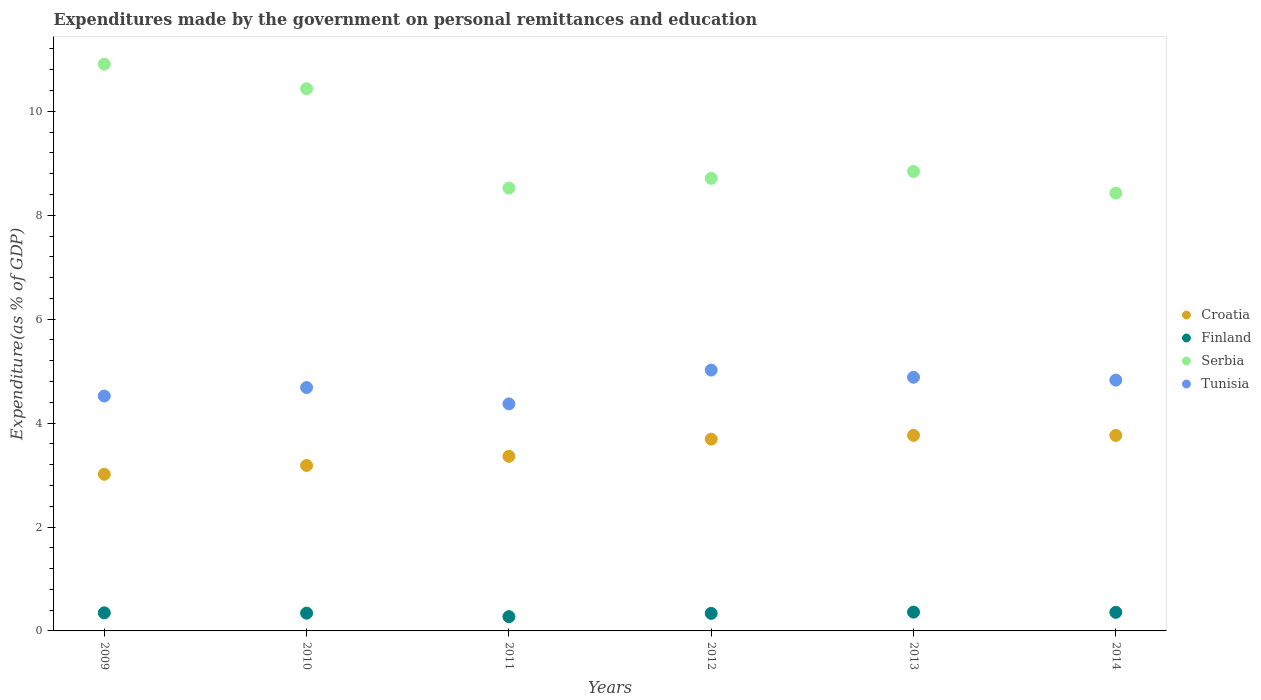Is the number of dotlines equal to the number of legend labels?
Make the answer very short. Yes. What is the expenditures made by the government on personal remittances and education in Serbia in 2010?
Offer a very short reply. 10.43. Across all years, what is the maximum expenditures made by the government on personal remittances and education in Serbia?
Your answer should be very brief. 10.91. Across all years, what is the minimum expenditures made by the government on personal remittances and education in Croatia?
Ensure brevity in your answer.  3.01. In which year was the expenditures made by the government on personal remittances and education in Croatia maximum?
Provide a succinct answer. 2013. In which year was the expenditures made by the government on personal remittances and education in Tunisia minimum?
Offer a very short reply. 2011. What is the total expenditures made by the government on personal remittances and education in Croatia in the graph?
Your response must be concise. 20.78. What is the difference between the expenditures made by the government on personal remittances and education in Serbia in 2009 and that in 2010?
Keep it short and to the point. 0.47. What is the difference between the expenditures made by the government on personal remittances and education in Croatia in 2011 and the expenditures made by the government on personal remittances and education in Finland in 2009?
Your answer should be very brief. 3.01. What is the average expenditures made by the government on personal remittances and education in Finland per year?
Make the answer very short. 0.34. In the year 2010, what is the difference between the expenditures made by the government on personal remittances and education in Croatia and expenditures made by the government on personal remittances and education in Tunisia?
Your answer should be compact. -1.5. What is the ratio of the expenditures made by the government on personal remittances and education in Serbia in 2012 to that in 2014?
Give a very brief answer. 1.03. Is the difference between the expenditures made by the government on personal remittances and education in Croatia in 2009 and 2011 greater than the difference between the expenditures made by the government on personal remittances and education in Tunisia in 2009 and 2011?
Your answer should be very brief. No. What is the difference between the highest and the second highest expenditures made by the government on personal remittances and education in Tunisia?
Ensure brevity in your answer.  0.14. What is the difference between the highest and the lowest expenditures made by the government on personal remittances and education in Finland?
Your answer should be very brief. 0.09. In how many years, is the expenditures made by the government on personal remittances and education in Croatia greater than the average expenditures made by the government on personal remittances and education in Croatia taken over all years?
Provide a short and direct response. 3. Is it the case that in every year, the sum of the expenditures made by the government on personal remittances and education in Finland and expenditures made by the government on personal remittances and education in Serbia  is greater than the sum of expenditures made by the government on personal remittances and education in Croatia and expenditures made by the government on personal remittances and education in Tunisia?
Ensure brevity in your answer.  No. Is it the case that in every year, the sum of the expenditures made by the government on personal remittances and education in Finland and expenditures made by the government on personal remittances and education in Serbia  is greater than the expenditures made by the government on personal remittances and education in Tunisia?
Your answer should be compact. Yes. Does the expenditures made by the government on personal remittances and education in Croatia monotonically increase over the years?
Your answer should be very brief. No. Does the graph contain grids?
Your answer should be very brief. No. Where does the legend appear in the graph?
Provide a short and direct response. Center right. How are the legend labels stacked?
Ensure brevity in your answer.  Vertical. What is the title of the graph?
Ensure brevity in your answer.  Expenditures made by the government on personal remittances and education. What is the label or title of the X-axis?
Offer a terse response. Years. What is the label or title of the Y-axis?
Provide a short and direct response. Expenditure(as % of GDP). What is the Expenditure(as % of GDP) of Croatia in 2009?
Keep it short and to the point. 3.01. What is the Expenditure(as % of GDP) of Finland in 2009?
Your response must be concise. 0.35. What is the Expenditure(as % of GDP) of Serbia in 2009?
Make the answer very short. 10.91. What is the Expenditure(as % of GDP) in Tunisia in 2009?
Your answer should be compact. 4.52. What is the Expenditure(as % of GDP) in Croatia in 2010?
Your answer should be compact. 3.18. What is the Expenditure(as % of GDP) in Finland in 2010?
Your response must be concise. 0.34. What is the Expenditure(as % of GDP) in Serbia in 2010?
Give a very brief answer. 10.43. What is the Expenditure(as % of GDP) of Tunisia in 2010?
Give a very brief answer. 4.68. What is the Expenditure(as % of GDP) of Croatia in 2011?
Offer a terse response. 3.36. What is the Expenditure(as % of GDP) in Finland in 2011?
Ensure brevity in your answer.  0.27. What is the Expenditure(as % of GDP) of Serbia in 2011?
Your answer should be very brief. 8.52. What is the Expenditure(as % of GDP) in Tunisia in 2011?
Offer a very short reply. 4.37. What is the Expenditure(as % of GDP) of Croatia in 2012?
Your response must be concise. 3.69. What is the Expenditure(as % of GDP) in Finland in 2012?
Provide a succinct answer. 0.34. What is the Expenditure(as % of GDP) of Serbia in 2012?
Give a very brief answer. 8.71. What is the Expenditure(as % of GDP) in Tunisia in 2012?
Provide a succinct answer. 5.02. What is the Expenditure(as % of GDP) of Croatia in 2013?
Keep it short and to the point. 3.76. What is the Expenditure(as % of GDP) of Finland in 2013?
Make the answer very short. 0.36. What is the Expenditure(as % of GDP) of Serbia in 2013?
Ensure brevity in your answer.  8.84. What is the Expenditure(as % of GDP) of Tunisia in 2013?
Your answer should be compact. 4.88. What is the Expenditure(as % of GDP) in Croatia in 2014?
Offer a very short reply. 3.76. What is the Expenditure(as % of GDP) of Finland in 2014?
Give a very brief answer. 0.36. What is the Expenditure(as % of GDP) in Serbia in 2014?
Ensure brevity in your answer.  8.43. What is the Expenditure(as % of GDP) of Tunisia in 2014?
Give a very brief answer. 4.83. Across all years, what is the maximum Expenditure(as % of GDP) of Croatia?
Offer a very short reply. 3.76. Across all years, what is the maximum Expenditure(as % of GDP) in Finland?
Provide a succinct answer. 0.36. Across all years, what is the maximum Expenditure(as % of GDP) in Serbia?
Keep it short and to the point. 10.91. Across all years, what is the maximum Expenditure(as % of GDP) in Tunisia?
Keep it short and to the point. 5.02. Across all years, what is the minimum Expenditure(as % of GDP) in Croatia?
Ensure brevity in your answer.  3.01. Across all years, what is the minimum Expenditure(as % of GDP) in Finland?
Offer a very short reply. 0.27. Across all years, what is the minimum Expenditure(as % of GDP) in Serbia?
Provide a short and direct response. 8.43. Across all years, what is the minimum Expenditure(as % of GDP) in Tunisia?
Keep it short and to the point. 4.37. What is the total Expenditure(as % of GDP) in Croatia in the graph?
Your answer should be compact. 20.78. What is the total Expenditure(as % of GDP) in Finland in the graph?
Your response must be concise. 2.02. What is the total Expenditure(as % of GDP) in Serbia in the graph?
Offer a very short reply. 55.84. What is the total Expenditure(as % of GDP) in Tunisia in the graph?
Your answer should be very brief. 28.3. What is the difference between the Expenditure(as % of GDP) in Croatia in 2009 and that in 2010?
Ensure brevity in your answer.  -0.17. What is the difference between the Expenditure(as % of GDP) of Finland in 2009 and that in 2010?
Offer a very short reply. 0.01. What is the difference between the Expenditure(as % of GDP) in Serbia in 2009 and that in 2010?
Provide a succinct answer. 0.47. What is the difference between the Expenditure(as % of GDP) of Tunisia in 2009 and that in 2010?
Your response must be concise. -0.16. What is the difference between the Expenditure(as % of GDP) of Croatia in 2009 and that in 2011?
Make the answer very short. -0.35. What is the difference between the Expenditure(as % of GDP) of Finland in 2009 and that in 2011?
Provide a short and direct response. 0.07. What is the difference between the Expenditure(as % of GDP) of Serbia in 2009 and that in 2011?
Keep it short and to the point. 2.38. What is the difference between the Expenditure(as % of GDP) in Tunisia in 2009 and that in 2011?
Your answer should be very brief. 0.15. What is the difference between the Expenditure(as % of GDP) of Croatia in 2009 and that in 2012?
Provide a succinct answer. -0.68. What is the difference between the Expenditure(as % of GDP) in Finland in 2009 and that in 2012?
Give a very brief answer. 0.01. What is the difference between the Expenditure(as % of GDP) in Serbia in 2009 and that in 2012?
Ensure brevity in your answer.  2.2. What is the difference between the Expenditure(as % of GDP) in Tunisia in 2009 and that in 2012?
Make the answer very short. -0.5. What is the difference between the Expenditure(as % of GDP) of Croatia in 2009 and that in 2013?
Your answer should be very brief. -0.75. What is the difference between the Expenditure(as % of GDP) in Finland in 2009 and that in 2013?
Provide a succinct answer. -0.01. What is the difference between the Expenditure(as % of GDP) of Serbia in 2009 and that in 2013?
Give a very brief answer. 2.06. What is the difference between the Expenditure(as % of GDP) in Tunisia in 2009 and that in 2013?
Your response must be concise. -0.36. What is the difference between the Expenditure(as % of GDP) in Croatia in 2009 and that in 2014?
Your answer should be compact. -0.75. What is the difference between the Expenditure(as % of GDP) in Finland in 2009 and that in 2014?
Your answer should be compact. -0.01. What is the difference between the Expenditure(as % of GDP) in Serbia in 2009 and that in 2014?
Make the answer very short. 2.48. What is the difference between the Expenditure(as % of GDP) in Tunisia in 2009 and that in 2014?
Ensure brevity in your answer.  -0.31. What is the difference between the Expenditure(as % of GDP) in Croatia in 2010 and that in 2011?
Ensure brevity in your answer.  -0.18. What is the difference between the Expenditure(as % of GDP) of Finland in 2010 and that in 2011?
Your answer should be very brief. 0.07. What is the difference between the Expenditure(as % of GDP) in Serbia in 2010 and that in 2011?
Your response must be concise. 1.91. What is the difference between the Expenditure(as % of GDP) of Tunisia in 2010 and that in 2011?
Offer a terse response. 0.31. What is the difference between the Expenditure(as % of GDP) of Croatia in 2010 and that in 2012?
Your response must be concise. -0.51. What is the difference between the Expenditure(as % of GDP) in Finland in 2010 and that in 2012?
Give a very brief answer. 0. What is the difference between the Expenditure(as % of GDP) of Serbia in 2010 and that in 2012?
Your answer should be compact. 1.72. What is the difference between the Expenditure(as % of GDP) in Tunisia in 2010 and that in 2012?
Offer a terse response. -0.34. What is the difference between the Expenditure(as % of GDP) of Croatia in 2010 and that in 2013?
Give a very brief answer. -0.58. What is the difference between the Expenditure(as % of GDP) in Finland in 2010 and that in 2013?
Provide a short and direct response. -0.02. What is the difference between the Expenditure(as % of GDP) in Serbia in 2010 and that in 2013?
Ensure brevity in your answer.  1.59. What is the difference between the Expenditure(as % of GDP) in Tunisia in 2010 and that in 2013?
Your answer should be compact. -0.2. What is the difference between the Expenditure(as % of GDP) of Croatia in 2010 and that in 2014?
Your answer should be very brief. -0.58. What is the difference between the Expenditure(as % of GDP) of Finland in 2010 and that in 2014?
Keep it short and to the point. -0.02. What is the difference between the Expenditure(as % of GDP) in Serbia in 2010 and that in 2014?
Offer a terse response. 2.01. What is the difference between the Expenditure(as % of GDP) in Tunisia in 2010 and that in 2014?
Your answer should be compact. -0.14. What is the difference between the Expenditure(as % of GDP) of Croatia in 2011 and that in 2012?
Offer a terse response. -0.33. What is the difference between the Expenditure(as % of GDP) of Finland in 2011 and that in 2012?
Offer a terse response. -0.06. What is the difference between the Expenditure(as % of GDP) in Serbia in 2011 and that in 2012?
Keep it short and to the point. -0.19. What is the difference between the Expenditure(as % of GDP) of Tunisia in 2011 and that in 2012?
Keep it short and to the point. -0.65. What is the difference between the Expenditure(as % of GDP) of Croatia in 2011 and that in 2013?
Your response must be concise. -0.4. What is the difference between the Expenditure(as % of GDP) of Finland in 2011 and that in 2013?
Your response must be concise. -0.09. What is the difference between the Expenditure(as % of GDP) in Serbia in 2011 and that in 2013?
Your answer should be very brief. -0.32. What is the difference between the Expenditure(as % of GDP) of Tunisia in 2011 and that in 2013?
Ensure brevity in your answer.  -0.51. What is the difference between the Expenditure(as % of GDP) in Croatia in 2011 and that in 2014?
Your answer should be very brief. -0.4. What is the difference between the Expenditure(as % of GDP) in Finland in 2011 and that in 2014?
Make the answer very short. -0.08. What is the difference between the Expenditure(as % of GDP) of Serbia in 2011 and that in 2014?
Offer a very short reply. 0.1. What is the difference between the Expenditure(as % of GDP) of Tunisia in 2011 and that in 2014?
Offer a very short reply. -0.46. What is the difference between the Expenditure(as % of GDP) in Croatia in 2012 and that in 2013?
Your answer should be very brief. -0.07. What is the difference between the Expenditure(as % of GDP) of Finland in 2012 and that in 2013?
Give a very brief answer. -0.02. What is the difference between the Expenditure(as % of GDP) of Serbia in 2012 and that in 2013?
Make the answer very short. -0.13. What is the difference between the Expenditure(as % of GDP) of Tunisia in 2012 and that in 2013?
Offer a terse response. 0.14. What is the difference between the Expenditure(as % of GDP) in Croatia in 2012 and that in 2014?
Your answer should be very brief. -0.07. What is the difference between the Expenditure(as % of GDP) in Finland in 2012 and that in 2014?
Your answer should be very brief. -0.02. What is the difference between the Expenditure(as % of GDP) of Serbia in 2012 and that in 2014?
Ensure brevity in your answer.  0.28. What is the difference between the Expenditure(as % of GDP) of Tunisia in 2012 and that in 2014?
Provide a succinct answer. 0.19. What is the difference between the Expenditure(as % of GDP) of Croatia in 2013 and that in 2014?
Keep it short and to the point. 0. What is the difference between the Expenditure(as % of GDP) of Finland in 2013 and that in 2014?
Your answer should be very brief. 0. What is the difference between the Expenditure(as % of GDP) of Serbia in 2013 and that in 2014?
Ensure brevity in your answer.  0.42. What is the difference between the Expenditure(as % of GDP) of Tunisia in 2013 and that in 2014?
Provide a succinct answer. 0.05. What is the difference between the Expenditure(as % of GDP) of Croatia in 2009 and the Expenditure(as % of GDP) of Finland in 2010?
Keep it short and to the point. 2.67. What is the difference between the Expenditure(as % of GDP) of Croatia in 2009 and the Expenditure(as % of GDP) of Serbia in 2010?
Offer a very short reply. -7.42. What is the difference between the Expenditure(as % of GDP) in Croatia in 2009 and the Expenditure(as % of GDP) in Tunisia in 2010?
Provide a short and direct response. -1.67. What is the difference between the Expenditure(as % of GDP) of Finland in 2009 and the Expenditure(as % of GDP) of Serbia in 2010?
Offer a terse response. -10.09. What is the difference between the Expenditure(as % of GDP) of Finland in 2009 and the Expenditure(as % of GDP) of Tunisia in 2010?
Keep it short and to the point. -4.34. What is the difference between the Expenditure(as % of GDP) in Serbia in 2009 and the Expenditure(as % of GDP) in Tunisia in 2010?
Make the answer very short. 6.22. What is the difference between the Expenditure(as % of GDP) of Croatia in 2009 and the Expenditure(as % of GDP) of Finland in 2011?
Make the answer very short. 2.74. What is the difference between the Expenditure(as % of GDP) in Croatia in 2009 and the Expenditure(as % of GDP) in Serbia in 2011?
Provide a succinct answer. -5.51. What is the difference between the Expenditure(as % of GDP) of Croatia in 2009 and the Expenditure(as % of GDP) of Tunisia in 2011?
Keep it short and to the point. -1.35. What is the difference between the Expenditure(as % of GDP) in Finland in 2009 and the Expenditure(as % of GDP) in Serbia in 2011?
Provide a succinct answer. -8.17. What is the difference between the Expenditure(as % of GDP) of Finland in 2009 and the Expenditure(as % of GDP) of Tunisia in 2011?
Provide a succinct answer. -4.02. What is the difference between the Expenditure(as % of GDP) of Serbia in 2009 and the Expenditure(as % of GDP) of Tunisia in 2011?
Offer a very short reply. 6.54. What is the difference between the Expenditure(as % of GDP) of Croatia in 2009 and the Expenditure(as % of GDP) of Finland in 2012?
Give a very brief answer. 2.68. What is the difference between the Expenditure(as % of GDP) of Croatia in 2009 and the Expenditure(as % of GDP) of Serbia in 2012?
Ensure brevity in your answer.  -5.7. What is the difference between the Expenditure(as % of GDP) of Croatia in 2009 and the Expenditure(as % of GDP) of Tunisia in 2012?
Make the answer very short. -2.01. What is the difference between the Expenditure(as % of GDP) of Finland in 2009 and the Expenditure(as % of GDP) of Serbia in 2012?
Your answer should be compact. -8.36. What is the difference between the Expenditure(as % of GDP) in Finland in 2009 and the Expenditure(as % of GDP) in Tunisia in 2012?
Make the answer very short. -4.67. What is the difference between the Expenditure(as % of GDP) of Serbia in 2009 and the Expenditure(as % of GDP) of Tunisia in 2012?
Provide a succinct answer. 5.89. What is the difference between the Expenditure(as % of GDP) of Croatia in 2009 and the Expenditure(as % of GDP) of Finland in 2013?
Provide a short and direct response. 2.65. What is the difference between the Expenditure(as % of GDP) in Croatia in 2009 and the Expenditure(as % of GDP) in Serbia in 2013?
Provide a succinct answer. -5.83. What is the difference between the Expenditure(as % of GDP) of Croatia in 2009 and the Expenditure(as % of GDP) of Tunisia in 2013?
Offer a terse response. -1.87. What is the difference between the Expenditure(as % of GDP) of Finland in 2009 and the Expenditure(as % of GDP) of Serbia in 2013?
Your response must be concise. -8.49. What is the difference between the Expenditure(as % of GDP) in Finland in 2009 and the Expenditure(as % of GDP) in Tunisia in 2013?
Offer a terse response. -4.53. What is the difference between the Expenditure(as % of GDP) in Serbia in 2009 and the Expenditure(as % of GDP) in Tunisia in 2013?
Provide a short and direct response. 6.03. What is the difference between the Expenditure(as % of GDP) of Croatia in 2009 and the Expenditure(as % of GDP) of Finland in 2014?
Your answer should be compact. 2.66. What is the difference between the Expenditure(as % of GDP) in Croatia in 2009 and the Expenditure(as % of GDP) in Serbia in 2014?
Ensure brevity in your answer.  -5.41. What is the difference between the Expenditure(as % of GDP) in Croatia in 2009 and the Expenditure(as % of GDP) in Tunisia in 2014?
Provide a short and direct response. -1.81. What is the difference between the Expenditure(as % of GDP) in Finland in 2009 and the Expenditure(as % of GDP) in Serbia in 2014?
Provide a succinct answer. -8.08. What is the difference between the Expenditure(as % of GDP) in Finland in 2009 and the Expenditure(as % of GDP) in Tunisia in 2014?
Provide a succinct answer. -4.48. What is the difference between the Expenditure(as % of GDP) in Serbia in 2009 and the Expenditure(as % of GDP) in Tunisia in 2014?
Make the answer very short. 6.08. What is the difference between the Expenditure(as % of GDP) in Croatia in 2010 and the Expenditure(as % of GDP) in Finland in 2011?
Make the answer very short. 2.91. What is the difference between the Expenditure(as % of GDP) of Croatia in 2010 and the Expenditure(as % of GDP) of Serbia in 2011?
Give a very brief answer. -5.34. What is the difference between the Expenditure(as % of GDP) of Croatia in 2010 and the Expenditure(as % of GDP) of Tunisia in 2011?
Give a very brief answer. -1.19. What is the difference between the Expenditure(as % of GDP) of Finland in 2010 and the Expenditure(as % of GDP) of Serbia in 2011?
Keep it short and to the point. -8.18. What is the difference between the Expenditure(as % of GDP) of Finland in 2010 and the Expenditure(as % of GDP) of Tunisia in 2011?
Give a very brief answer. -4.03. What is the difference between the Expenditure(as % of GDP) of Serbia in 2010 and the Expenditure(as % of GDP) of Tunisia in 2011?
Your answer should be compact. 6.07. What is the difference between the Expenditure(as % of GDP) of Croatia in 2010 and the Expenditure(as % of GDP) of Finland in 2012?
Make the answer very short. 2.85. What is the difference between the Expenditure(as % of GDP) in Croatia in 2010 and the Expenditure(as % of GDP) in Serbia in 2012?
Your answer should be very brief. -5.53. What is the difference between the Expenditure(as % of GDP) of Croatia in 2010 and the Expenditure(as % of GDP) of Tunisia in 2012?
Provide a succinct answer. -1.84. What is the difference between the Expenditure(as % of GDP) of Finland in 2010 and the Expenditure(as % of GDP) of Serbia in 2012?
Your answer should be compact. -8.37. What is the difference between the Expenditure(as % of GDP) in Finland in 2010 and the Expenditure(as % of GDP) in Tunisia in 2012?
Provide a short and direct response. -4.68. What is the difference between the Expenditure(as % of GDP) of Serbia in 2010 and the Expenditure(as % of GDP) of Tunisia in 2012?
Offer a very short reply. 5.41. What is the difference between the Expenditure(as % of GDP) in Croatia in 2010 and the Expenditure(as % of GDP) in Finland in 2013?
Provide a succinct answer. 2.82. What is the difference between the Expenditure(as % of GDP) in Croatia in 2010 and the Expenditure(as % of GDP) in Serbia in 2013?
Give a very brief answer. -5.66. What is the difference between the Expenditure(as % of GDP) in Croatia in 2010 and the Expenditure(as % of GDP) in Tunisia in 2013?
Provide a short and direct response. -1.7. What is the difference between the Expenditure(as % of GDP) of Finland in 2010 and the Expenditure(as % of GDP) of Serbia in 2013?
Your answer should be compact. -8.5. What is the difference between the Expenditure(as % of GDP) in Finland in 2010 and the Expenditure(as % of GDP) in Tunisia in 2013?
Your answer should be compact. -4.54. What is the difference between the Expenditure(as % of GDP) of Serbia in 2010 and the Expenditure(as % of GDP) of Tunisia in 2013?
Your answer should be compact. 5.55. What is the difference between the Expenditure(as % of GDP) in Croatia in 2010 and the Expenditure(as % of GDP) in Finland in 2014?
Your response must be concise. 2.83. What is the difference between the Expenditure(as % of GDP) in Croatia in 2010 and the Expenditure(as % of GDP) in Serbia in 2014?
Give a very brief answer. -5.24. What is the difference between the Expenditure(as % of GDP) of Croatia in 2010 and the Expenditure(as % of GDP) of Tunisia in 2014?
Provide a succinct answer. -1.64. What is the difference between the Expenditure(as % of GDP) of Finland in 2010 and the Expenditure(as % of GDP) of Serbia in 2014?
Ensure brevity in your answer.  -8.08. What is the difference between the Expenditure(as % of GDP) in Finland in 2010 and the Expenditure(as % of GDP) in Tunisia in 2014?
Your answer should be compact. -4.49. What is the difference between the Expenditure(as % of GDP) in Serbia in 2010 and the Expenditure(as % of GDP) in Tunisia in 2014?
Offer a very short reply. 5.61. What is the difference between the Expenditure(as % of GDP) of Croatia in 2011 and the Expenditure(as % of GDP) of Finland in 2012?
Ensure brevity in your answer.  3.02. What is the difference between the Expenditure(as % of GDP) in Croatia in 2011 and the Expenditure(as % of GDP) in Serbia in 2012?
Your response must be concise. -5.35. What is the difference between the Expenditure(as % of GDP) in Croatia in 2011 and the Expenditure(as % of GDP) in Tunisia in 2012?
Provide a succinct answer. -1.66. What is the difference between the Expenditure(as % of GDP) of Finland in 2011 and the Expenditure(as % of GDP) of Serbia in 2012?
Your answer should be compact. -8.44. What is the difference between the Expenditure(as % of GDP) of Finland in 2011 and the Expenditure(as % of GDP) of Tunisia in 2012?
Your answer should be compact. -4.75. What is the difference between the Expenditure(as % of GDP) in Serbia in 2011 and the Expenditure(as % of GDP) in Tunisia in 2012?
Give a very brief answer. 3.5. What is the difference between the Expenditure(as % of GDP) of Croatia in 2011 and the Expenditure(as % of GDP) of Finland in 2013?
Keep it short and to the point. 3. What is the difference between the Expenditure(as % of GDP) in Croatia in 2011 and the Expenditure(as % of GDP) in Serbia in 2013?
Provide a succinct answer. -5.48. What is the difference between the Expenditure(as % of GDP) of Croatia in 2011 and the Expenditure(as % of GDP) of Tunisia in 2013?
Provide a succinct answer. -1.52. What is the difference between the Expenditure(as % of GDP) of Finland in 2011 and the Expenditure(as % of GDP) of Serbia in 2013?
Provide a succinct answer. -8.57. What is the difference between the Expenditure(as % of GDP) in Finland in 2011 and the Expenditure(as % of GDP) in Tunisia in 2013?
Keep it short and to the point. -4.61. What is the difference between the Expenditure(as % of GDP) in Serbia in 2011 and the Expenditure(as % of GDP) in Tunisia in 2013?
Offer a terse response. 3.64. What is the difference between the Expenditure(as % of GDP) in Croatia in 2011 and the Expenditure(as % of GDP) in Finland in 2014?
Keep it short and to the point. 3. What is the difference between the Expenditure(as % of GDP) of Croatia in 2011 and the Expenditure(as % of GDP) of Serbia in 2014?
Give a very brief answer. -5.07. What is the difference between the Expenditure(as % of GDP) of Croatia in 2011 and the Expenditure(as % of GDP) of Tunisia in 2014?
Offer a terse response. -1.47. What is the difference between the Expenditure(as % of GDP) in Finland in 2011 and the Expenditure(as % of GDP) in Serbia in 2014?
Keep it short and to the point. -8.15. What is the difference between the Expenditure(as % of GDP) in Finland in 2011 and the Expenditure(as % of GDP) in Tunisia in 2014?
Provide a short and direct response. -4.55. What is the difference between the Expenditure(as % of GDP) in Serbia in 2011 and the Expenditure(as % of GDP) in Tunisia in 2014?
Your answer should be compact. 3.7. What is the difference between the Expenditure(as % of GDP) of Croatia in 2012 and the Expenditure(as % of GDP) of Finland in 2013?
Give a very brief answer. 3.33. What is the difference between the Expenditure(as % of GDP) of Croatia in 2012 and the Expenditure(as % of GDP) of Serbia in 2013?
Provide a succinct answer. -5.15. What is the difference between the Expenditure(as % of GDP) of Croatia in 2012 and the Expenditure(as % of GDP) of Tunisia in 2013?
Offer a terse response. -1.19. What is the difference between the Expenditure(as % of GDP) of Finland in 2012 and the Expenditure(as % of GDP) of Serbia in 2013?
Make the answer very short. -8.51. What is the difference between the Expenditure(as % of GDP) in Finland in 2012 and the Expenditure(as % of GDP) in Tunisia in 2013?
Your response must be concise. -4.54. What is the difference between the Expenditure(as % of GDP) of Serbia in 2012 and the Expenditure(as % of GDP) of Tunisia in 2013?
Make the answer very short. 3.83. What is the difference between the Expenditure(as % of GDP) of Croatia in 2012 and the Expenditure(as % of GDP) of Finland in 2014?
Provide a short and direct response. 3.33. What is the difference between the Expenditure(as % of GDP) in Croatia in 2012 and the Expenditure(as % of GDP) in Serbia in 2014?
Make the answer very short. -4.73. What is the difference between the Expenditure(as % of GDP) in Croatia in 2012 and the Expenditure(as % of GDP) in Tunisia in 2014?
Provide a short and direct response. -1.14. What is the difference between the Expenditure(as % of GDP) in Finland in 2012 and the Expenditure(as % of GDP) in Serbia in 2014?
Ensure brevity in your answer.  -8.09. What is the difference between the Expenditure(as % of GDP) of Finland in 2012 and the Expenditure(as % of GDP) of Tunisia in 2014?
Offer a terse response. -4.49. What is the difference between the Expenditure(as % of GDP) of Serbia in 2012 and the Expenditure(as % of GDP) of Tunisia in 2014?
Your response must be concise. 3.88. What is the difference between the Expenditure(as % of GDP) of Croatia in 2013 and the Expenditure(as % of GDP) of Finland in 2014?
Provide a succinct answer. 3.41. What is the difference between the Expenditure(as % of GDP) in Croatia in 2013 and the Expenditure(as % of GDP) in Serbia in 2014?
Ensure brevity in your answer.  -4.66. What is the difference between the Expenditure(as % of GDP) in Croatia in 2013 and the Expenditure(as % of GDP) in Tunisia in 2014?
Offer a very short reply. -1.06. What is the difference between the Expenditure(as % of GDP) of Finland in 2013 and the Expenditure(as % of GDP) of Serbia in 2014?
Your answer should be very brief. -8.06. What is the difference between the Expenditure(as % of GDP) of Finland in 2013 and the Expenditure(as % of GDP) of Tunisia in 2014?
Ensure brevity in your answer.  -4.47. What is the difference between the Expenditure(as % of GDP) in Serbia in 2013 and the Expenditure(as % of GDP) in Tunisia in 2014?
Ensure brevity in your answer.  4.02. What is the average Expenditure(as % of GDP) of Croatia per year?
Your answer should be compact. 3.46. What is the average Expenditure(as % of GDP) of Finland per year?
Offer a terse response. 0.34. What is the average Expenditure(as % of GDP) in Serbia per year?
Offer a very short reply. 9.31. What is the average Expenditure(as % of GDP) in Tunisia per year?
Your answer should be very brief. 4.72. In the year 2009, what is the difference between the Expenditure(as % of GDP) of Croatia and Expenditure(as % of GDP) of Finland?
Offer a terse response. 2.67. In the year 2009, what is the difference between the Expenditure(as % of GDP) in Croatia and Expenditure(as % of GDP) in Serbia?
Your answer should be very brief. -7.89. In the year 2009, what is the difference between the Expenditure(as % of GDP) in Croatia and Expenditure(as % of GDP) in Tunisia?
Your response must be concise. -1.51. In the year 2009, what is the difference between the Expenditure(as % of GDP) of Finland and Expenditure(as % of GDP) of Serbia?
Your answer should be compact. -10.56. In the year 2009, what is the difference between the Expenditure(as % of GDP) in Finland and Expenditure(as % of GDP) in Tunisia?
Your response must be concise. -4.17. In the year 2009, what is the difference between the Expenditure(as % of GDP) in Serbia and Expenditure(as % of GDP) in Tunisia?
Keep it short and to the point. 6.39. In the year 2010, what is the difference between the Expenditure(as % of GDP) of Croatia and Expenditure(as % of GDP) of Finland?
Give a very brief answer. 2.84. In the year 2010, what is the difference between the Expenditure(as % of GDP) in Croatia and Expenditure(as % of GDP) in Serbia?
Your answer should be compact. -7.25. In the year 2010, what is the difference between the Expenditure(as % of GDP) of Croatia and Expenditure(as % of GDP) of Tunisia?
Your answer should be compact. -1.5. In the year 2010, what is the difference between the Expenditure(as % of GDP) of Finland and Expenditure(as % of GDP) of Serbia?
Offer a terse response. -10.09. In the year 2010, what is the difference between the Expenditure(as % of GDP) in Finland and Expenditure(as % of GDP) in Tunisia?
Ensure brevity in your answer.  -4.34. In the year 2010, what is the difference between the Expenditure(as % of GDP) of Serbia and Expenditure(as % of GDP) of Tunisia?
Provide a succinct answer. 5.75. In the year 2011, what is the difference between the Expenditure(as % of GDP) in Croatia and Expenditure(as % of GDP) in Finland?
Provide a succinct answer. 3.09. In the year 2011, what is the difference between the Expenditure(as % of GDP) of Croatia and Expenditure(as % of GDP) of Serbia?
Make the answer very short. -5.16. In the year 2011, what is the difference between the Expenditure(as % of GDP) in Croatia and Expenditure(as % of GDP) in Tunisia?
Your answer should be compact. -1.01. In the year 2011, what is the difference between the Expenditure(as % of GDP) in Finland and Expenditure(as % of GDP) in Serbia?
Offer a very short reply. -8.25. In the year 2011, what is the difference between the Expenditure(as % of GDP) in Finland and Expenditure(as % of GDP) in Tunisia?
Make the answer very short. -4.09. In the year 2011, what is the difference between the Expenditure(as % of GDP) of Serbia and Expenditure(as % of GDP) of Tunisia?
Offer a very short reply. 4.15. In the year 2012, what is the difference between the Expenditure(as % of GDP) of Croatia and Expenditure(as % of GDP) of Finland?
Your response must be concise. 3.35. In the year 2012, what is the difference between the Expenditure(as % of GDP) in Croatia and Expenditure(as % of GDP) in Serbia?
Provide a succinct answer. -5.02. In the year 2012, what is the difference between the Expenditure(as % of GDP) in Croatia and Expenditure(as % of GDP) in Tunisia?
Ensure brevity in your answer.  -1.33. In the year 2012, what is the difference between the Expenditure(as % of GDP) in Finland and Expenditure(as % of GDP) in Serbia?
Your answer should be compact. -8.37. In the year 2012, what is the difference between the Expenditure(as % of GDP) of Finland and Expenditure(as % of GDP) of Tunisia?
Provide a short and direct response. -4.68. In the year 2012, what is the difference between the Expenditure(as % of GDP) of Serbia and Expenditure(as % of GDP) of Tunisia?
Provide a succinct answer. 3.69. In the year 2013, what is the difference between the Expenditure(as % of GDP) in Croatia and Expenditure(as % of GDP) in Finland?
Offer a terse response. 3.4. In the year 2013, what is the difference between the Expenditure(as % of GDP) in Croatia and Expenditure(as % of GDP) in Serbia?
Your answer should be compact. -5.08. In the year 2013, what is the difference between the Expenditure(as % of GDP) in Croatia and Expenditure(as % of GDP) in Tunisia?
Offer a very short reply. -1.12. In the year 2013, what is the difference between the Expenditure(as % of GDP) in Finland and Expenditure(as % of GDP) in Serbia?
Provide a succinct answer. -8.48. In the year 2013, what is the difference between the Expenditure(as % of GDP) in Finland and Expenditure(as % of GDP) in Tunisia?
Make the answer very short. -4.52. In the year 2013, what is the difference between the Expenditure(as % of GDP) in Serbia and Expenditure(as % of GDP) in Tunisia?
Give a very brief answer. 3.96. In the year 2014, what is the difference between the Expenditure(as % of GDP) of Croatia and Expenditure(as % of GDP) of Finland?
Give a very brief answer. 3.4. In the year 2014, what is the difference between the Expenditure(as % of GDP) of Croatia and Expenditure(as % of GDP) of Serbia?
Keep it short and to the point. -4.66. In the year 2014, what is the difference between the Expenditure(as % of GDP) in Croatia and Expenditure(as % of GDP) in Tunisia?
Offer a very short reply. -1.06. In the year 2014, what is the difference between the Expenditure(as % of GDP) of Finland and Expenditure(as % of GDP) of Serbia?
Your response must be concise. -8.07. In the year 2014, what is the difference between the Expenditure(as % of GDP) of Finland and Expenditure(as % of GDP) of Tunisia?
Offer a very short reply. -4.47. In the year 2014, what is the difference between the Expenditure(as % of GDP) of Serbia and Expenditure(as % of GDP) of Tunisia?
Your answer should be very brief. 3.6. What is the ratio of the Expenditure(as % of GDP) in Croatia in 2009 to that in 2010?
Offer a very short reply. 0.95. What is the ratio of the Expenditure(as % of GDP) in Finland in 2009 to that in 2010?
Give a very brief answer. 1.02. What is the ratio of the Expenditure(as % of GDP) of Serbia in 2009 to that in 2010?
Your response must be concise. 1.05. What is the ratio of the Expenditure(as % of GDP) in Tunisia in 2009 to that in 2010?
Keep it short and to the point. 0.97. What is the ratio of the Expenditure(as % of GDP) of Croatia in 2009 to that in 2011?
Your response must be concise. 0.9. What is the ratio of the Expenditure(as % of GDP) of Finland in 2009 to that in 2011?
Provide a succinct answer. 1.27. What is the ratio of the Expenditure(as % of GDP) in Serbia in 2009 to that in 2011?
Make the answer very short. 1.28. What is the ratio of the Expenditure(as % of GDP) of Tunisia in 2009 to that in 2011?
Give a very brief answer. 1.03. What is the ratio of the Expenditure(as % of GDP) of Croatia in 2009 to that in 2012?
Provide a succinct answer. 0.82. What is the ratio of the Expenditure(as % of GDP) in Finland in 2009 to that in 2012?
Give a very brief answer. 1.03. What is the ratio of the Expenditure(as % of GDP) in Serbia in 2009 to that in 2012?
Give a very brief answer. 1.25. What is the ratio of the Expenditure(as % of GDP) in Tunisia in 2009 to that in 2012?
Your answer should be compact. 0.9. What is the ratio of the Expenditure(as % of GDP) in Croatia in 2009 to that in 2013?
Make the answer very short. 0.8. What is the ratio of the Expenditure(as % of GDP) in Serbia in 2009 to that in 2013?
Your answer should be very brief. 1.23. What is the ratio of the Expenditure(as % of GDP) in Tunisia in 2009 to that in 2013?
Your answer should be compact. 0.93. What is the ratio of the Expenditure(as % of GDP) in Croatia in 2009 to that in 2014?
Offer a very short reply. 0.8. What is the ratio of the Expenditure(as % of GDP) in Finland in 2009 to that in 2014?
Your answer should be compact. 0.97. What is the ratio of the Expenditure(as % of GDP) in Serbia in 2009 to that in 2014?
Your answer should be very brief. 1.29. What is the ratio of the Expenditure(as % of GDP) in Tunisia in 2009 to that in 2014?
Your answer should be compact. 0.94. What is the ratio of the Expenditure(as % of GDP) in Croatia in 2010 to that in 2011?
Your response must be concise. 0.95. What is the ratio of the Expenditure(as % of GDP) of Finland in 2010 to that in 2011?
Give a very brief answer. 1.25. What is the ratio of the Expenditure(as % of GDP) of Serbia in 2010 to that in 2011?
Your answer should be very brief. 1.22. What is the ratio of the Expenditure(as % of GDP) of Tunisia in 2010 to that in 2011?
Make the answer very short. 1.07. What is the ratio of the Expenditure(as % of GDP) in Croatia in 2010 to that in 2012?
Keep it short and to the point. 0.86. What is the ratio of the Expenditure(as % of GDP) of Finland in 2010 to that in 2012?
Ensure brevity in your answer.  1.01. What is the ratio of the Expenditure(as % of GDP) in Serbia in 2010 to that in 2012?
Offer a terse response. 1.2. What is the ratio of the Expenditure(as % of GDP) in Tunisia in 2010 to that in 2012?
Provide a short and direct response. 0.93. What is the ratio of the Expenditure(as % of GDP) of Croatia in 2010 to that in 2013?
Ensure brevity in your answer.  0.85. What is the ratio of the Expenditure(as % of GDP) of Finland in 2010 to that in 2013?
Keep it short and to the point. 0.95. What is the ratio of the Expenditure(as % of GDP) of Serbia in 2010 to that in 2013?
Give a very brief answer. 1.18. What is the ratio of the Expenditure(as % of GDP) in Tunisia in 2010 to that in 2013?
Provide a short and direct response. 0.96. What is the ratio of the Expenditure(as % of GDP) of Croatia in 2010 to that in 2014?
Your response must be concise. 0.85. What is the ratio of the Expenditure(as % of GDP) in Finland in 2010 to that in 2014?
Provide a succinct answer. 0.96. What is the ratio of the Expenditure(as % of GDP) of Serbia in 2010 to that in 2014?
Give a very brief answer. 1.24. What is the ratio of the Expenditure(as % of GDP) in Tunisia in 2010 to that in 2014?
Your answer should be compact. 0.97. What is the ratio of the Expenditure(as % of GDP) in Croatia in 2011 to that in 2012?
Keep it short and to the point. 0.91. What is the ratio of the Expenditure(as % of GDP) of Finland in 2011 to that in 2012?
Give a very brief answer. 0.81. What is the ratio of the Expenditure(as % of GDP) in Serbia in 2011 to that in 2012?
Offer a very short reply. 0.98. What is the ratio of the Expenditure(as % of GDP) of Tunisia in 2011 to that in 2012?
Ensure brevity in your answer.  0.87. What is the ratio of the Expenditure(as % of GDP) in Croatia in 2011 to that in 2013?
Your response must be concise. 0.89. What is the ratio of the Expenditure(as % of GDP) in Finland in 2011 to that in 2013?
Make the answer very short. 0.76. What is the ratio of the Expenditure(as % of GDP) of Serbia in 2011 to that in 2013?
Keep it short and to the point. 0.96. What is the ratio of the Expenditure(as % of GDP) in Tunisia in 2011 to that in 2013?
Offer a terse response. 0.9. What is the ratio of the Expenditure(as % of GDP) of Croatia in 2011 to that in 2014?
Provide a short and direct response. 0.89. What is the ratio of the Expenditure(as % of GDP) of Finland in 2011 to that in 2014?
Your response must be concise. 0.77. What is the ratio of the Expenditure(as % of GDP) of Serbia in 2011 to that in 2014?
Keep it short and to the point. 1.01. What is the ratio of the Expenditure(as % of GDP) in Tunisia in 2011 to that in 2014?
Offer a terse response. 0.91. What is the ratio of the Expenditure(as % of GDP) in Croatia in 2012 to that in 2013?
Provide a succinct answer. 0.98. What is the ratio of the Expenditure(as % of GDP) of Finland in 2012 to that in 2013?
Ensure brevity in your answer.  0.93. What is the ratio of the Expenditure(as % of GDP) in Serbia in 2012 to that in 2013?
Offer a terse response. 0.98. What is the ratio of the Expenditure(as % of GDP) in Tunisia in 2012 to that in 2013?
Give a very brief answer. 1.03. What is the ratio of the Expenditure(as % of GDP) of Croatia in 2012 to that in 2014?
Offer a very short reply. 0.98. What is the ratio of the Expenditure(as % of GDP) of Finland in 2012 to that in 2014?
Provide a succinct answer. 0.94. What is the ratio of the Expenditure(as % of GDP) of Serbia in 2012 to that in 2014?
Your answer should be very brief. 1.03. What is the ratio of the Expenditure(as % of GDP) in Finland in 2013 to that in 2014?
Your answer should be compact. 1.01. What is the ratio of the Expenditure(as % of GDP) in Serbia in 2013 to that in 2014?
Offer a very short reply. 1.05. What is the ratio of the Expenditure(as % of GDP) in Tunisia in 2013 to that in 2014?
Provide a succinct answer. 1.01. What is the difference between the highest and the second highest Expenditure(as % of GDP) in Croatia?
Make the answer very short. 0. What is the difference between the highest and the second highest Expenditure(as % of GDP) of Finland?
Offer a terse response. 0. What is the difference between the highest and the second highest Expenditure(as % of GDP) of Serbia?
Offer a very short reply. 0.47. What is the difference between the highest and the second highest Expenditure(as % of GDP) in Tunisia?
Make the answer very short. 0.14. What is the difference between the highest and the lowest Expenditure(as % of GDP) in Croatia?
Provide a succinct answer. 0.75. What is the difference between the highest and the lowest Expenditure(as % of GDP) in Finland?
Your answer should be very brief. 0.09. What is the difference between the highest and the lowest Expenditure(as % of GDP) in Serbia?
Give a very brief answer. 2.48. What is the difference between the highest and the lowest Expenditure(as % of GDP) of Tunisia?
Your response must be concise. 0.65. 